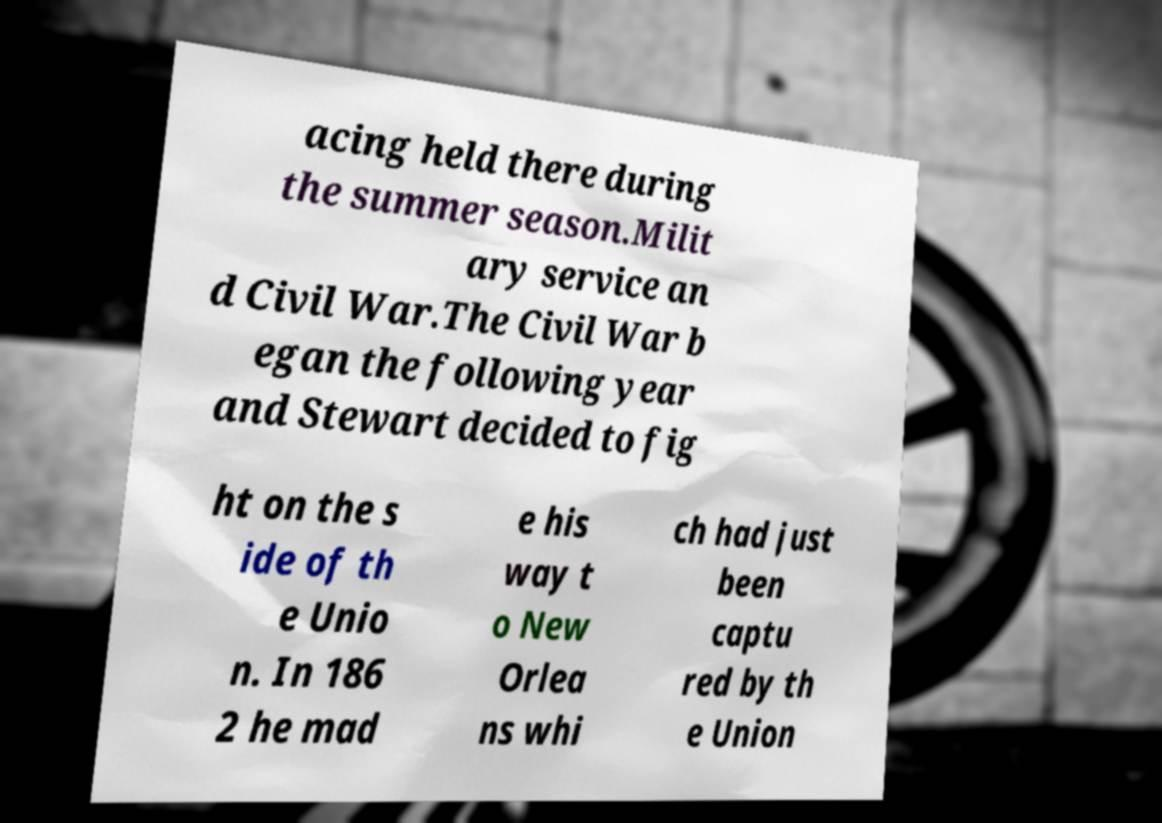Please read and relay the text visible in this image. What does it say? acing held there during the summer season.Milit ary service an d Civil War.The Civil War b egan the following year and Stewart decided to fig ht on the s ide of th e Unio n. In 186 2 he mad e his way t o New Orlea ns whi ch had just been captu red by th e Union 